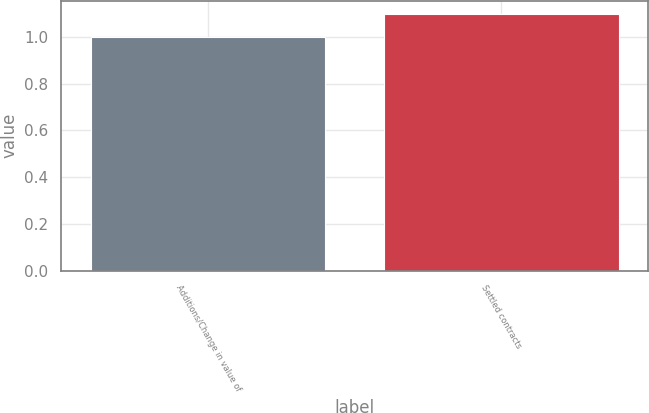Convert chart. <chart><loc_0><loc_0><loc_500><loc_500><bar_chart><fcel>Additions/Change in value of<fcel>Settled contracts<nl><fcel>1<fcel>1.1<nl></chart> 